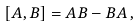<formula> <loc_0><loc_0><loc_500><loc_500>[ A , B ] = A B - B A \, ,</formula> 